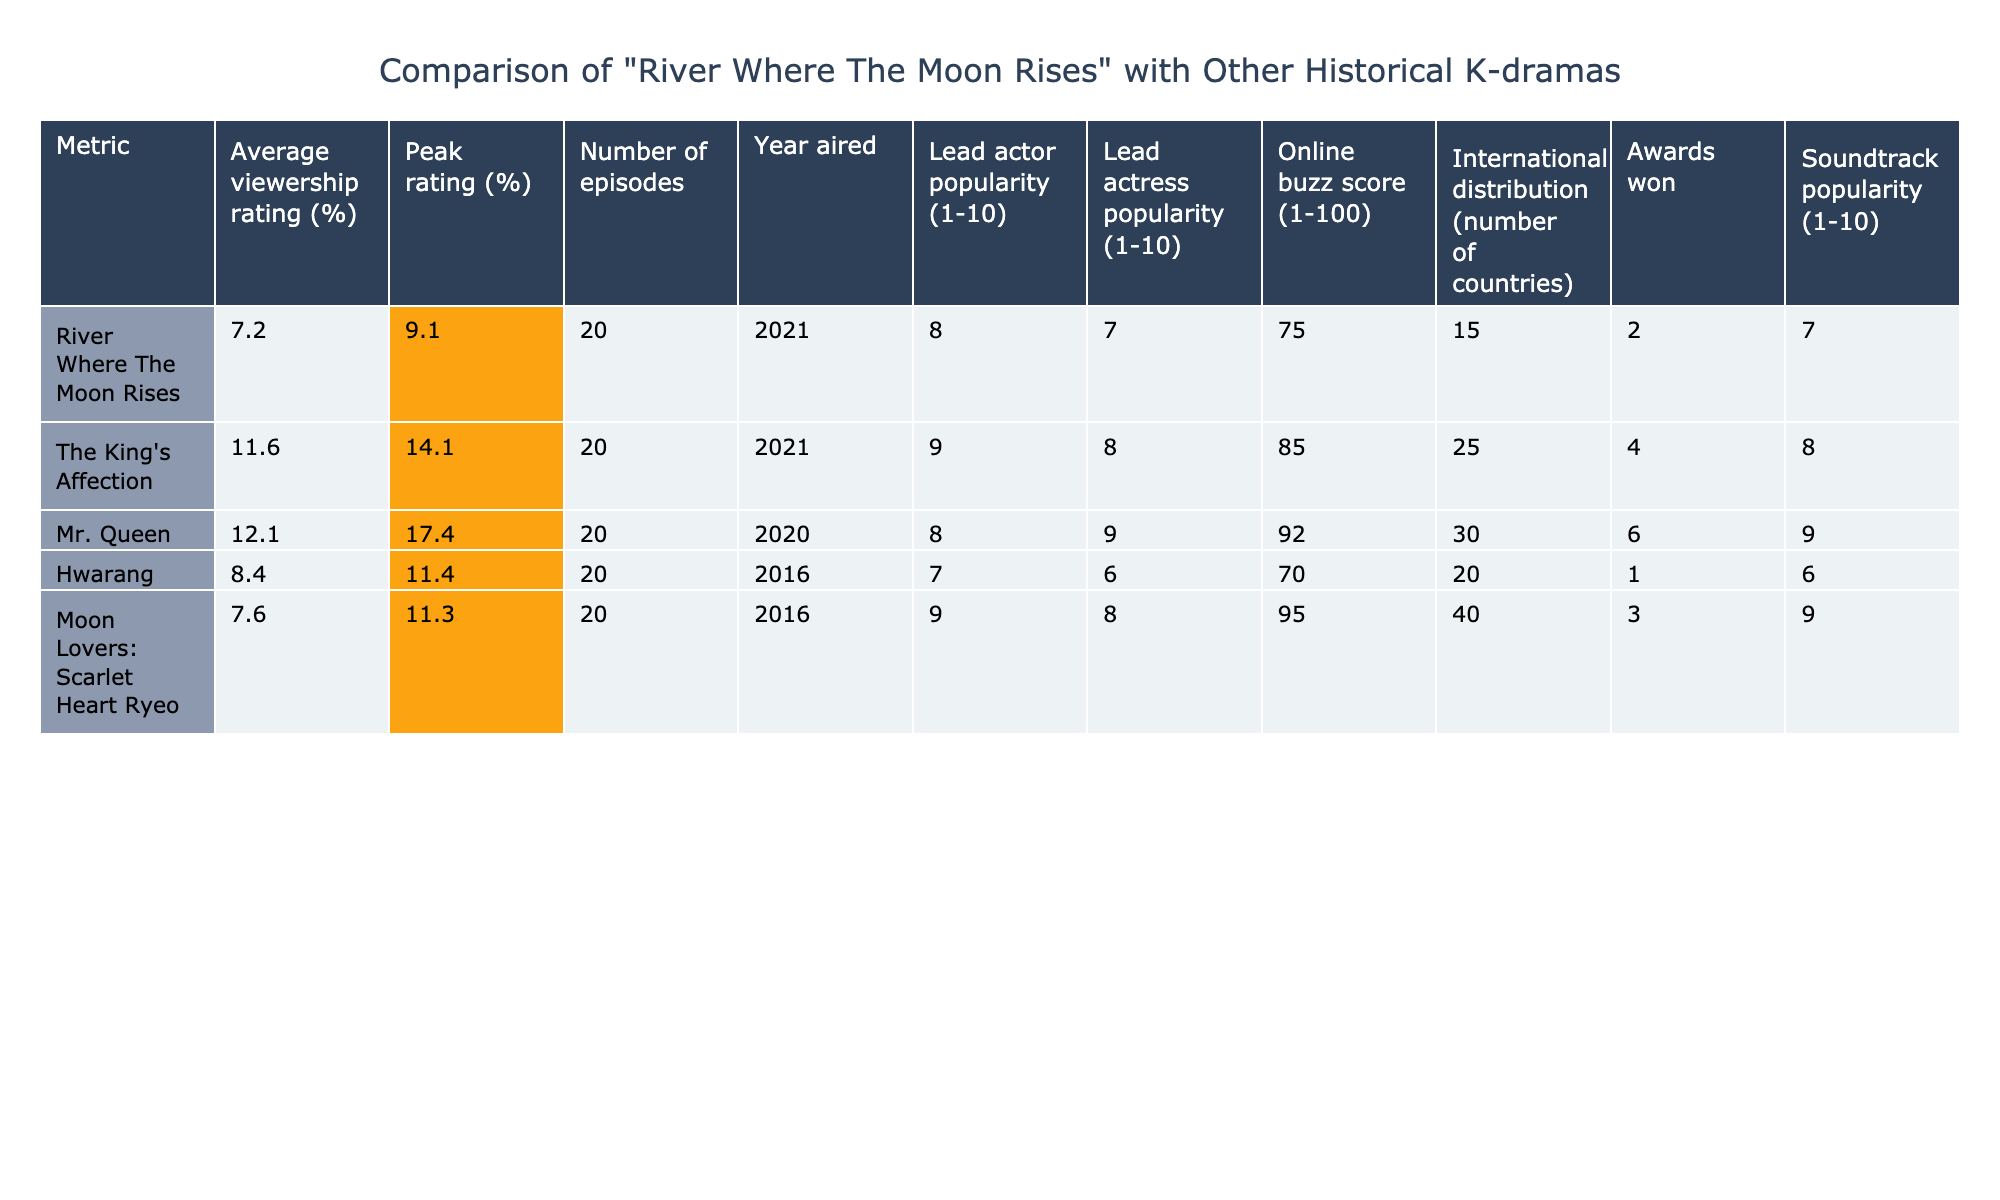What is the average viewership rating of "River Where The Moon Rises"? The table shows that the average viewership rating for "River Where The Moon Rises" is 7.2%.
Answer: 7.2% Which historical K-drama has the highest peak rating? The peak rating of "Mr. Queen" is 17.4%, which is the highest among the listed dramas.
Answer: Mr. Queen How many episodes does "The King's Affection" have? The table indicates that "The King's Affection" has 20 episodes.
Answer: 20 What is the online buzz score for "Moon Lovers: Scarlet Heart Ryeo"? According to the table, "Moon Lovers: Scarlet Heart Ryeo" has an online buzz score of 95.
Answer: 95 Which K-drama won the most awards? The table states that "Mr. Queen" won 6 awards, making it the drama with the most awards.
Answer: Mr. Queen What is the difference between the average viewership ratings of "River Where The Moon Rises" and "Hwarang"? "River Where The Moon Rises" has an average rating of 7.2% and "Hwarang" has an average rating of 8.4%. The difference is 8.4% - 7.2% = 1.2%.
Answer: 1.2% Is the lead actress popularity for "Mr. Queen" greater than that for "Hwarang"? The lead actress popularity for "Mr. Queen" is 9, while for "Hwarang" it is 6. Therefore, the statement is true.
Answer: Yes Which K-drama has the least international distribution? The table shows that "River Where The Moon Rises" has international distribution in 15 countries, which is the least among the listed dramas.
Answer: River Where The Moon Rises Considering the lead actor and actress popularity, which K-drama has the highest combined score? "The King's Affection" has a lead actor popularity of 9 and a lead actress popularity of 8, resulting in a combined score of 9 + 8 = 17. This is the highest combined score among the listed dramas.
Answer: The King's Affection Which K-drama aired more recently, "Hwarang" or "Mr. Queen"? The table indicates that "Mr. Queen" aired in 2020 and "Hwarang" aired in 2016. Therefore, "Mr. Queen" aired more recently.
Answer: Mr. Queen 